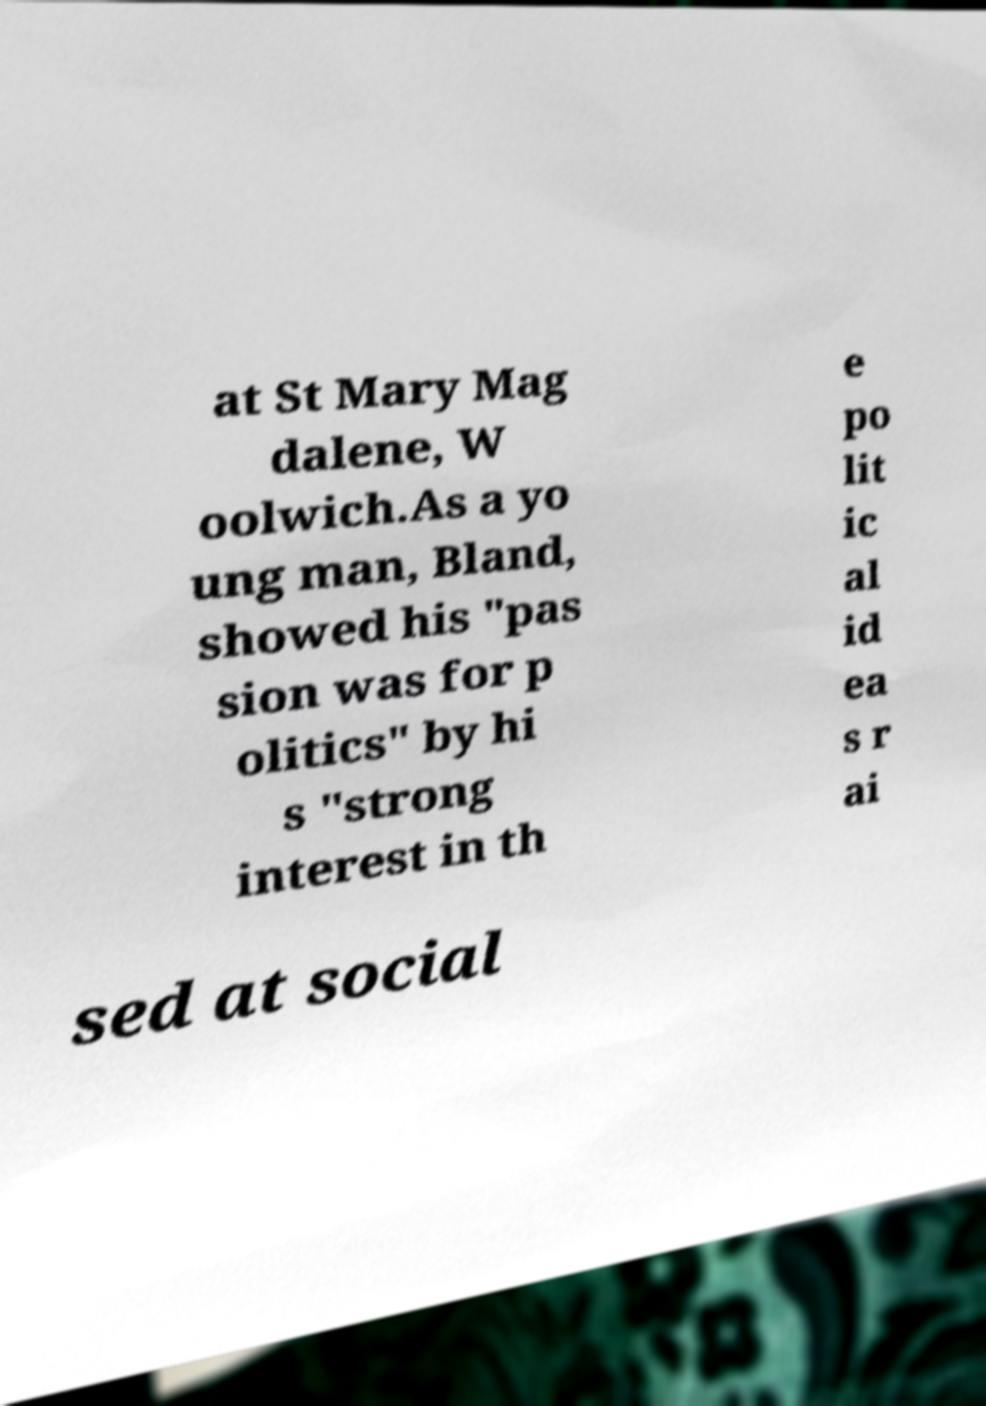There's text embedded in this image that I need extracted. Can you transcribe it verbatim? at St Mary Mag dalene, W oolwich.As a yo ung man, Bland, showed his "pas sion was for p olitics" by hi s "strong interest in th e po lit ic al id ea s r ai sed at social 